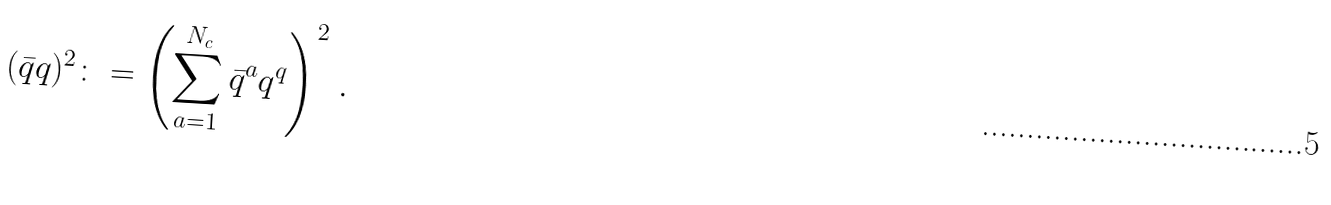Convert formula to latex. <formula><loc_0><loc_0><loc_500><loc_500>( \bar { q } q ) ^ { 2 } \colon = \left ( \sum _ { a = 1 } ^ { N _ { c } } \bar { q } ^ { a } q ^ { q } \right ) ^ { 2 } \, .</formula> 